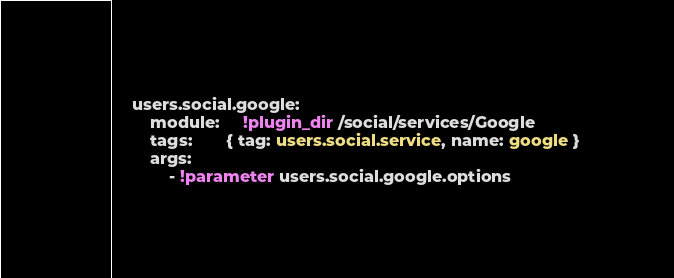<code> <loc_0><loc_0><loc_500><loc_500><_YAML_>    users.social.google:
        module:     !plugin_dir /social/services/Google
        tags:       { tag: users.social.service, name: google }
        args:
            - !parameter users.social.google.options
</code> 